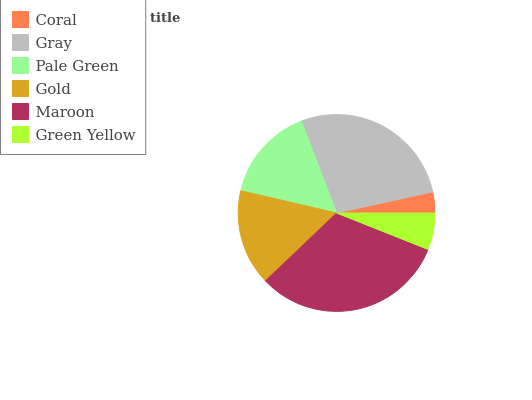Is Coral the minimum?
Answer yes or no. Yes. Is Maroon the maximum?
Answer yes or no. Yes. Is Gray the minimum?
Answer yes or no. No. Is Gray the maximum?
Answer yes or no. No. Is Gray greater than Coral?
Answer yes or no. Yes. Is Coral less than Gray?
Answer yes or no. Yes. Is Coral greater than Gray?
Answer yes or no. No. Is Gray less than Coral?
Answer yes or no. No. Is Gold the high median?
Answer yes or no. Yes. Is Pale Green the low median?
Answer yes or no. Yes. Is Green Yellow the high median?
Answer yes or no. No. Is Gray the low median?
Answer yes or no. No. 